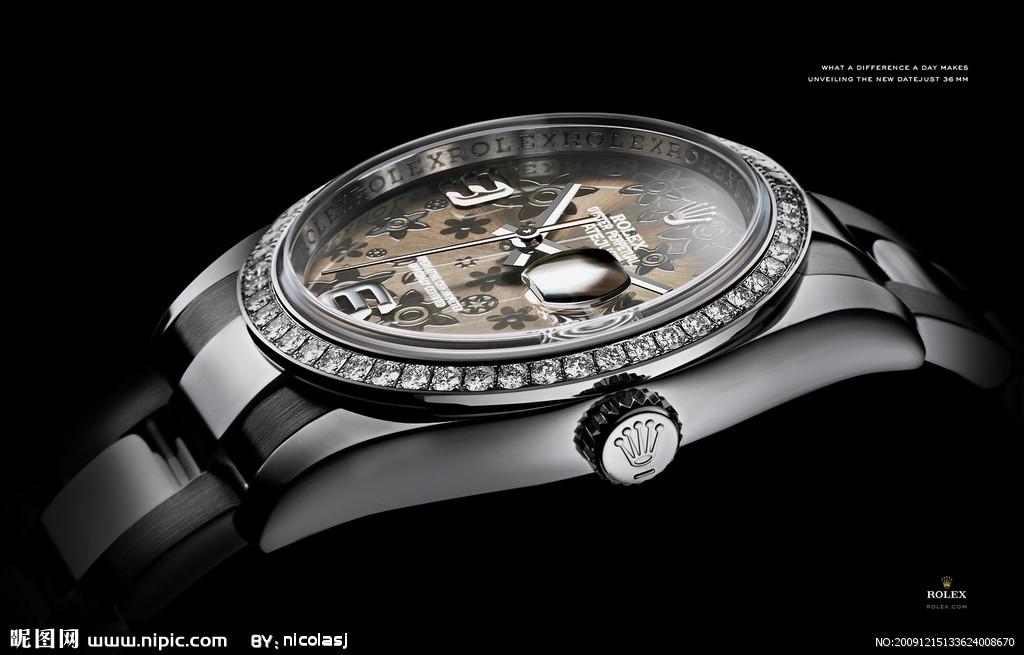Is nipic the brand?
Offer a terse response. No. What is the url at the bottom of the ad?
Make the answer very short. Www.nipic.com. 